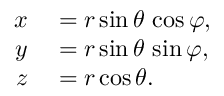Convert formula to latex. <formula><loc_0><loc_0><loc_500><loc_500>\begin{array} { r l } { x } & = r \sin \theta \, \cos \varphi , } \\ { y } & = r \sin \theta \, \sin \varphi , } \\ { z } & = r \cos \theta . } \end{array}</formula> 